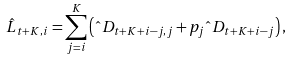Convert formula to latex. <formula><loc_0><loc_0><loc_500><loc_500>\hat { L } _ { t + K , i } = \sum _ { j = i } ^ { K } \left ( \hat { \ } D _ { t + K + i - j , j } + p _ { j } \hat { \ } D _ { t + K + i - j } \right ) ,</formula> 